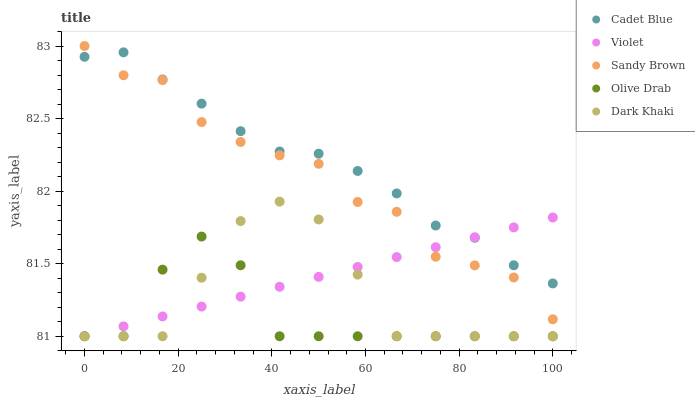Does Olive Drab have the minimum area under the curve?
Answer yes or no. Yes. Does Cadet Blue have the maximum area under the curve?
Answer yes or no. Yes. Does Sandy Brown have the minimum area under the curve?
Answer yes or no. No. Does Sandy Brown have the maximum area under the curve?
Answer yes or no. No. Is Violet the smoothest?
Answer yes or no. Yes. Is Olive Drab the roughest?
Answer yes or no. Yes. Is Cadet Blue the smoothest?
Answer yes or no. No. Is Cadet Blue the roughest?
Answer yes or no. No. Does Dark Khaki have the lowest value?
Answer yes or no. Yes. Does Sandy Brown have the lowest value?
Answer yes or no. No. Does Sandy Brown have the highest value?
Answer yes or no. Yes. Does Cadet Blue have the highest value?
Answer yes or no. No. Is Dark Khaki less than Sandy Brown?
Answer yes or no. Yes. Is Sandy Brown greater than Dark Khaki?
Answer yes or no. Yes. Does Dark Khaki intersect Violet?
Answer yes or no. Yes. Is Dark Khaki less than Violet?
Answer yes or no. No. Is Dark Khaki greater than Violet?
Answer yes or no. No. Does Dark Khaki intersect Sandy Brown?
Answer yes or no. No. 